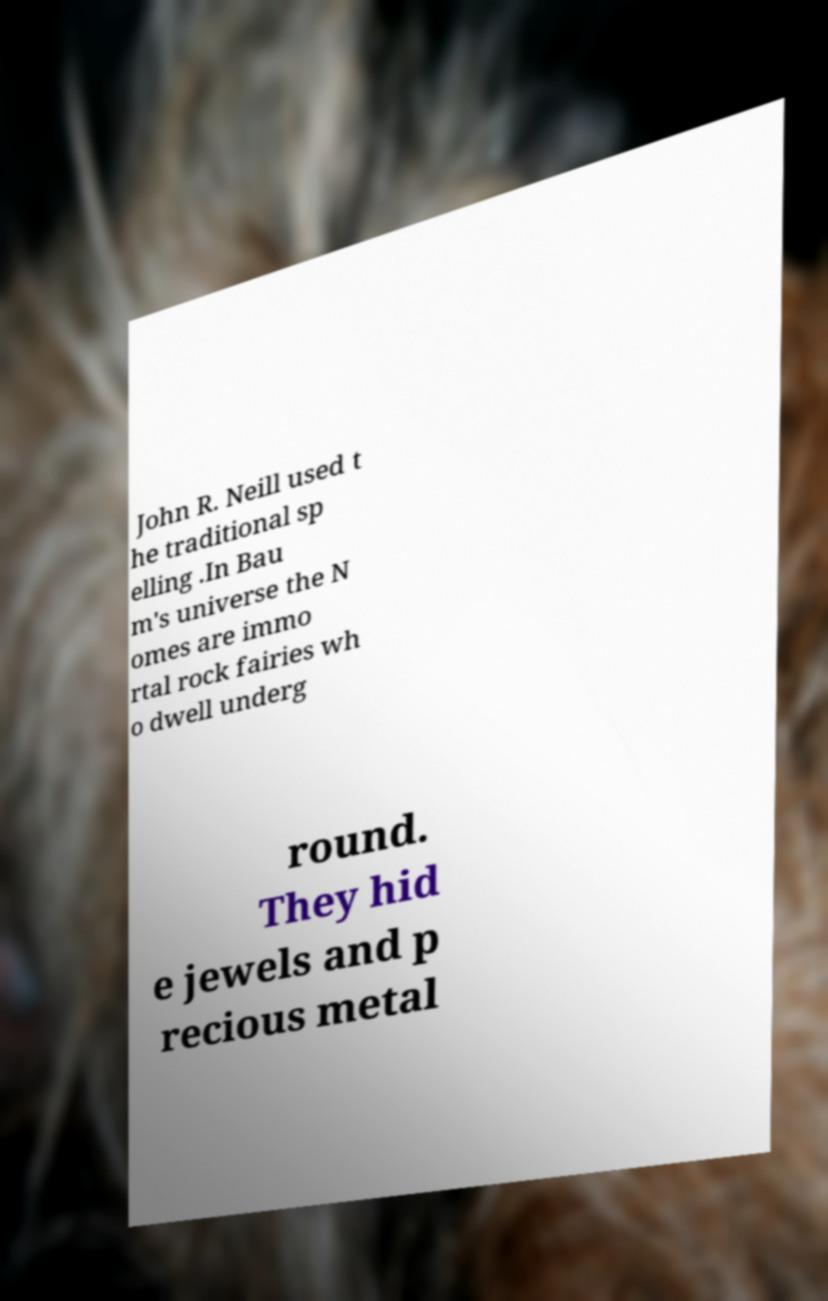Could you assist in decoding the text presented in this image and type it out clearly? John R. Neill used t he traditional sp elling .In Bau m's universe the N omes are immo rtal rock fairies wh o dwell underg round. They hid e jewels and p recious metal 